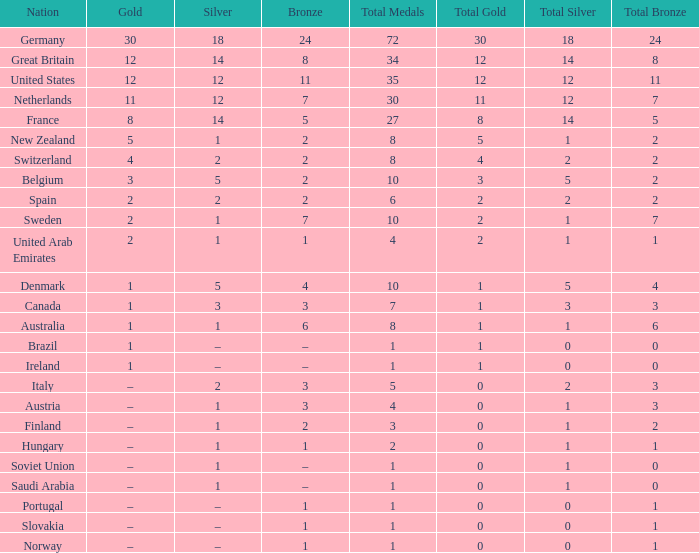What is the total number of Total, when Silver is 1, and when Bronze is 7? 1.0. 